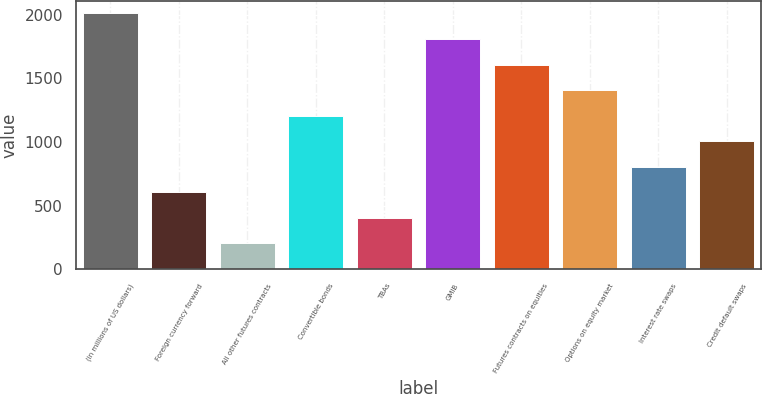Convert chart to OTSL. <chart><loc_0><loc_0><loc_500><loc_500><bar_chart><fcel>(in millions of US dollars)<fcel>Foreign currency forward<fcel>All other futures contracts<fcel>Convertible bonds<fcel>TBAs<fcel>GMIB<fcel>Futures contracts on equities<fcel>Options on equity market<fcel>Interest rate swaps<fcel>Credit default swaps<nl><fcel>2009<fcel>605.5<fcel>204.5<fcel>1207<fcel>405<fcel>1808.5<fcel>1608<fcel>1407.5<fcel>806<fcel>1006.5<nl></chart> 